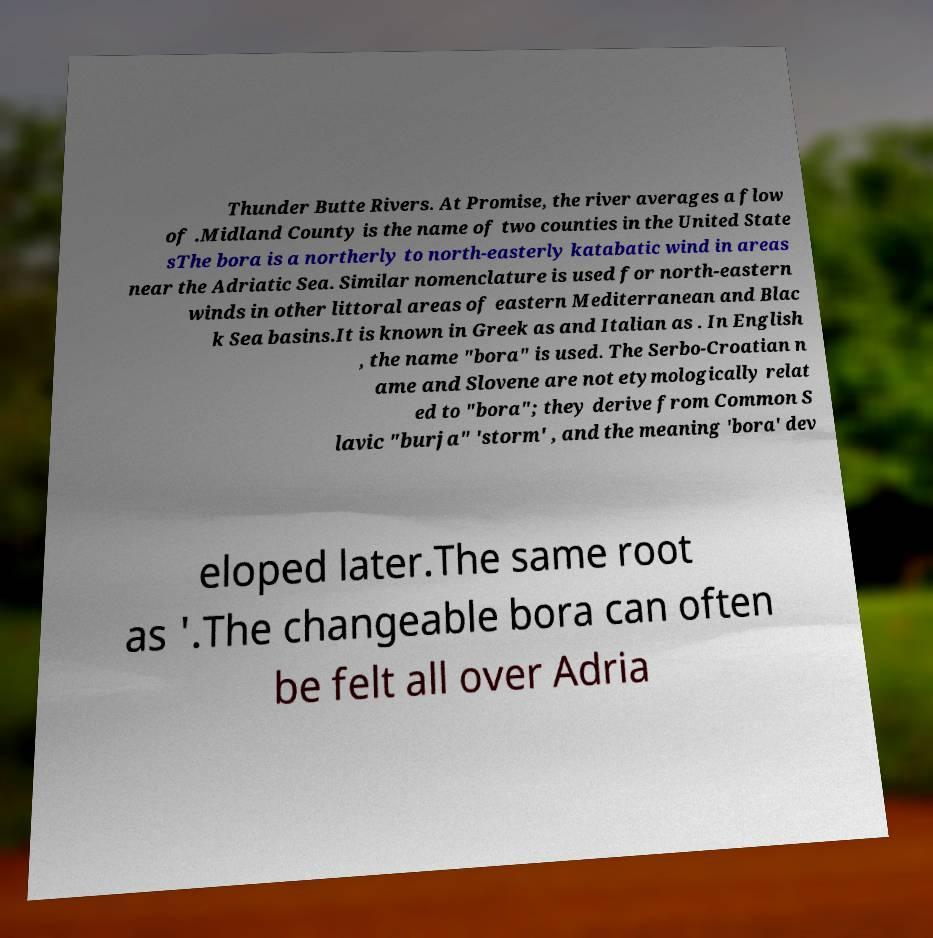Please identify and transcribe the text found in this image. Thunder Butte Rivers. At Promise, the river averages a flow of .Midland County is the name of two counties in the United State sThe bora is a northerly to north-easterly katabatic wind in areas near the Adriatic Sea. Similar nomenclature is used for north-eastern winds in other littoral areas of eastern Mediterranean and Blac k Sea basins.It is known in Greek as and Italian as . In English , the name "bora" is used. The Serbo-Croatian n ame and Slovene are not etymologically relat ed to "bora"; they derive from Common S lavic "burja" 'storm' , and the meaning 'bora' dev eloped later.The same root as '.The changeable bora can often be felt all over Adria 